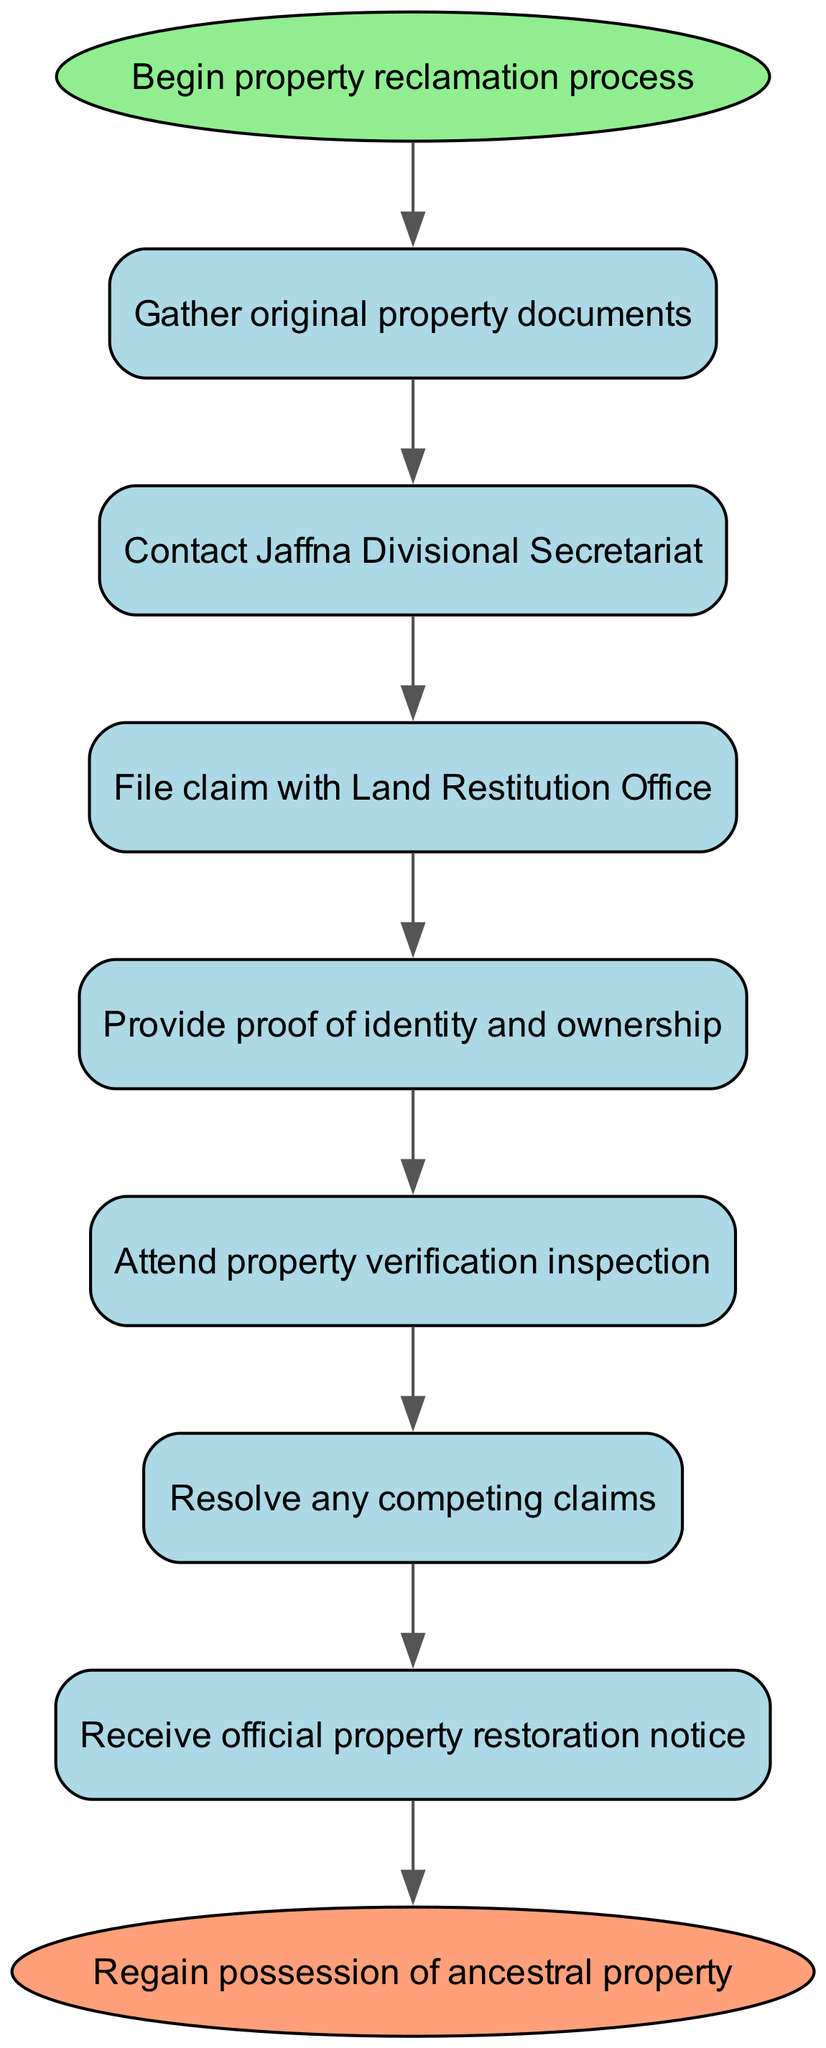What is the first step in the property reclamation process? The flow chart starts with the "Begin property reclamation process" node, which indicates the initiation of the process. The first step after this is to "Gather original property documents."
Answer: Gather original property documents How many steps are there in the property reclamation process? By counting the nodes from the flow chart, excluding the start and end nodes, there are six specific steps that must be completed to reclaim property.
Answer: Six What is required after contacting the Jaffna Divisional Secretariat? The chart shows that after contacting the Jaffna Divisional Secretariat, the next node indicates to "File claim with Land Restitution Office."
Answer: File claim with Land Restitution Office What do you need to provide before attending the property verification inspection? The flow chart specifies that before attending the property verification inspection, one must "Provide proof of identity and ownership."
Answer: Provide proof of identity and ownership What happens after resolving any competing claims? According to the diagram, after resolving any competing claims, the next step is to "Receive official property restoration notice." This indicates that resolution leads to the official acknowledgment of the claim.
Answer: Receive official property restoration notice What is the purpose of the "Attend property verification inspection" step? The "Attend property verification inspection" step serves to confirm the claim and validate the property's current status as part of the reclamation process, ensuring all details align with the submitted documents and claims.
Answer: Confirm the claim and validate status What is the final outcome of following all the steps? The last node in the flow chart explicitly states the final outcome, which is to "Regain possession of ancestral property," after completing all preceding steps.
Answer: Regain possession of ancestral property How does one resolve competing claims? The flow chart does not specify the exact method for resolving competing claims, but it indicates that this step is crucial and must happen before receiving the official notice, highlighting the importance of legal or mediatory actions during this process.
Answer: Legal or mediatory actions What type of diagram is this? This diagram represents a flow chart of an instruction specifically tailored to illustrate the sequential steps involved in reclaiming property in Jaffna.
Answer: Flow chart of an instruction 